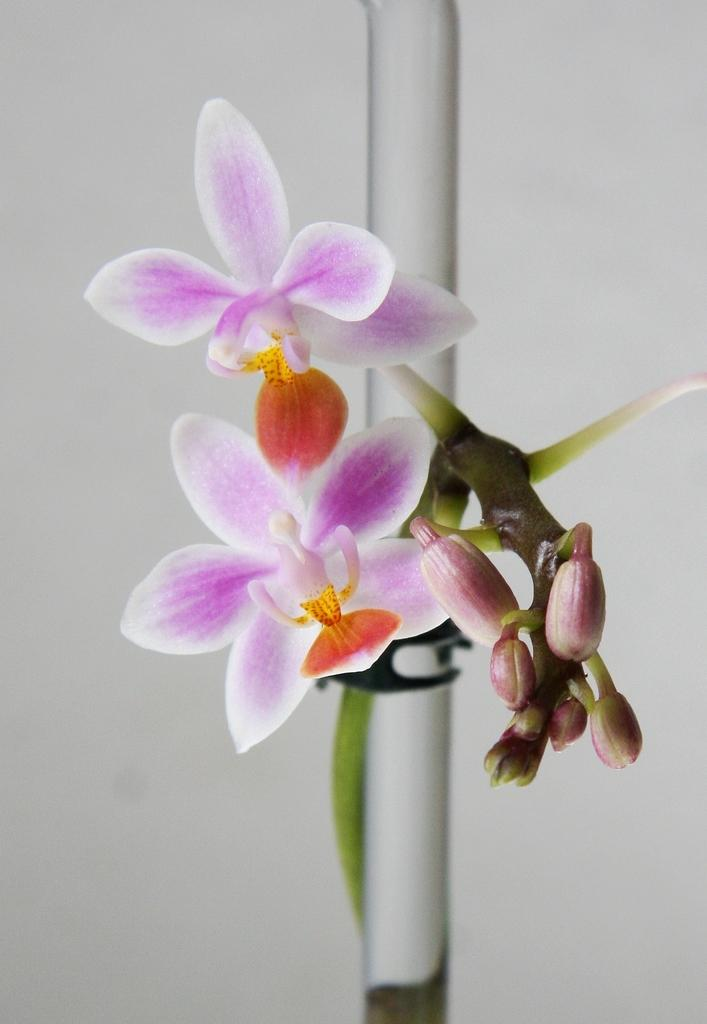What types of plants are in the image? There are flowers in the image. What stage of growth are some of the flowers in? There are buds in the image. What colors can be seen in the flowers? The flowers are in purple, white, and orange colors. What color is the background of the image? The background of the image is white. What type of business is being conducted in the image? There is no indication of any business activity in the image; it features flowers and buds. What things are the flowers doing in the image? The flowers are not performing any actions or activities in the image; they are simply present as part of the scene. 